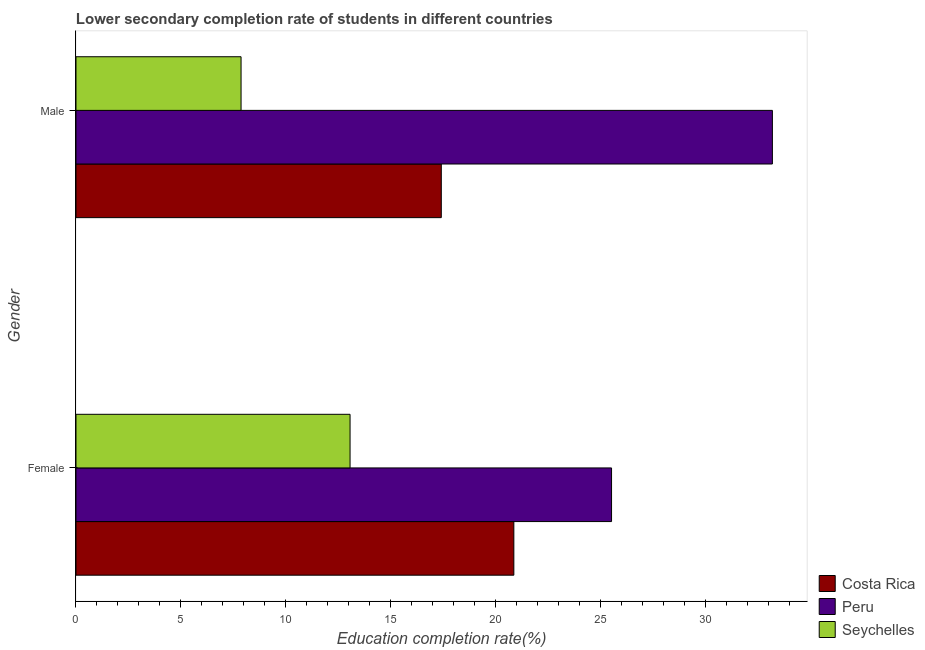What is the label of the 2nd group of bars from the top?
Your response must be concise. Female. What is the education completion rate of female students in Peru?
Your response must be concise. 25.52. Across all countries, what is the maximum education completion rate of female students?
Ensure brevity in your answer.  25.52. Across all countries, what is the minimum education completion rate of female students?
Give a very brief answer. 13.06. In which country was the education completion rate of male students maximum?
Your response must be concise. Peru. In which country was the education completion rate of male students minimum?
Provide a succinct answer. Seychelles. What is the total education completion rate of female students in the graph?
Give a very brief answer. 59.44. What is the difference between the education completion rate of female students in Seychelles and that in Costa Rica?
Give a very brief answer. -7.8. What is the difference between the education completion rate of male students in Peru and the education completion rate of female students in Costa Rica?
Provide a succinct answer. 12.32. What is the average education completion rate of male students per country?
Provide a succinct answer. 19.48. What is the difference between the education completion rate of male students and education completion rate of female students in Peru?
Give a very brief answer. 7.66. What is the ratio of the education completion rate of male students in Costa Rica to that in Seychelles?
Your response must be concise. 2.21. What does the 2nd bar from the top in Female represents?
Provide a short and direct response. Peru. What does the 3rd bar from the bottom in Male represents?
Provide a succinct answer. Seychelles. How many countries are there in the graph?
Offer a terse response. 3. Does the graph contain any zero values?
Offer a very short reply. No. Where does the legend appear in the graph?
Offer a very short reply. Bottom right. How many legend labels are there?
Make the answer very short. 3. How are the legend labels stacked?
Offer a terse response. Vertical. What is the title of the graph?
Provide a short and direct response. Lower secondary completion rate of students in different countries. What is the label or title of the X-axis?
Give a very brief answer. Education completion rate(%). What is the Education completion rate(%) in Costa Rica in Female?
Offer a terse response. 20.86. What is the Education completion rate(%) of Peru in Female?
Keep it short and to the point. 25.52. What is the Education completion rate(%) of Seychelles in Female?
Offer a terse response. 13.06. What is the Education completion rate(%) of Costa Rica in Male?
Your answer should be compact. 17.41. What is the Education completion rate(%) of Peru in Male?
Offer a very short reply. 33.18. What is the Education completion rate(%) in Seychelles in Male?
Keep it short and to the point. 7.87. Across all Gender, what is the maximum Education completion rate(%) in Costa Rica?
Offer a terse response. 20.86. Across all Gender, what is the maximum Education completion rate(%) of Peru?
Offer a terse response. 33.18. Across all Gender, what is the maximum Education completion rate(%) of Seychelles?
Offer a very short reply. 13.06. Across all Gender, what is the minimum Education completion rate(%) of Costa Rica?
Keep it short and to the point. 17.41. Across all Gender, what is the minimum Education completion rate(%) of Peru?
Offer a very short reply. 25.52. Across all Gender, what is the minimum Education completion rate(%) of Seychelles?
Your answer should be compact. 7.87. What is the total Education completion rate(%) of Costa Rica in the graph?
Provide a short and direct response. 38.27. What is the total Education completion rate(%) of Peru in the graph?
Keep it short and to the point. 58.7. What is the total Education completion rate(%) in Seychelles in the graph?
Keep it short and to the point. 20.92. What is the difference between the Education completion rate(%) of Costa Rica in Female and that in Male?
Your response must be concise. 3.46. What is the difference between the Education completion rate(%) in Peru in Female and that in Male?
Provide a short and direct response. -7.66. What is the difference between the Education completion rate(%) in Seychelles in Female and that in Male?
Your answer should be compact. 5.19. What is the difference between the Education completion rate(%) of Costa Rica in Female and the Education completion rate(%) of Peru in Male?
Provide a succinct answer. -12.32. What is the difference between the Education completion rate(%) of Costa Rica in Female and the Education completion rate(%) of Seychelles in Male?
Ensure brevity in your answer.  13. What is the difference between the Education completion rate(%) in Peru in Female and the Education completion rate(%) in Seychelles in Male?
Offer a terse response. 17.65. What is the average Education completion rate(%) in Costa Rica per Gender?
Offer a very short reply. 19.13. What is the average Education completion rate(%) in Peru per Gender?
Offer a terse response. 29.35. What is the average Education completion rate(%) of Seychelles per Gender?
Provide a short and direct response. 10.46. What is the difference between the Education completion rate(%) of Costa Rica and Education completion rate(%) of Peru in Female?
Offer a terse response. -4.65. What is the difference between the Education completion rate(%) of Costa Rica and Education completion rate(%) of Seychelles in Female?
Your response must be concise. 7.8. What is the difference between the Education completion rate(%) in Peru and Education completion rate(%) in Seychelles in Female?
Your response must be concise. 12.46. What is the difference between the Education completion rate(%) of Costa Rica and Education completion rate(%) of Peru in Male?
Offer a very short reply. -15.78. What is the difference between the Education completion rate(%) of Costa Rica and Education completion rate(%) of Seychelles in Male?
Your answer should be compact. 9.54. What is the difference between the Education completion rate(%) in Peru and Education completion rate(%) in Seychelles in Male?
Your response must be concise. 25.32. What is the ratio of the Education completion rate(%) in Costa Rica in Female to that in Male?
Give a very brief answer. 1.2. What is the ratio of the Education completion rate(%) in Peru in Female to that in Male?
Your response must be concise. 0.77. What is the ratio of the Education completion rate(%) of Seychelles in Female to that in Male?
Your response must be concise. 1.66. What is the difference between the highest and the second highest Education completion rate(%) of Costa Rica?
Offer a very short reply. 3.46. What is the difference between the highest and the second highest Education completion rate(%) in Peru?
Provide a succinct answer. 7.66. What is the difference between the highest and the second highest Education completion rate(%) of Seychelles?
Your response must be concise. 5.19. What is the difference between the highest and the lowest Education completion rate(%) of Costa Rica?
Your response must be concise. 3.46. What is the difference between the highest and the lowest Education completion rate(%) of Peru?
Provide a succinct answer. 7.66. What is the difference between the highest and the lowest Education completion rate(%) in Seychelles?
Provide a succinct answer. 5.19. 